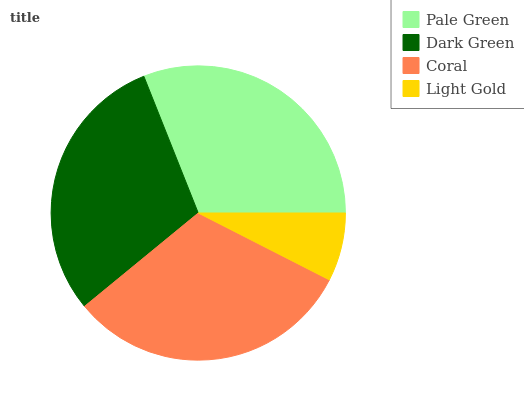Is Light Gold the minimum?
Answer yes or no. Yes. Is Coral the maximum?
Answer yes or no. Yes. Is Dark Green the minimum?
Answer yes or no. No. Is Dark Green the maximum?
Answer yes or no. No. Is Pale Green greater than Dark Green?
Answer yes or no. Yes. Is Dark Green less than Pale Green?
Answer yes or no. Yes. Is Dark Green greater than Pale Green?
Answer yes or no. No. Is Pale Green less than Dark Green?
Answer yes or no. No. Is Pale Green the high median?
Answer yes or no. Yes. Is Dark Green the low median?
Answer yes or no. Yes. Is Coral the high median?
Answer yes or no. No. Is Pale Green the low median?
Answer yes or no. No. 